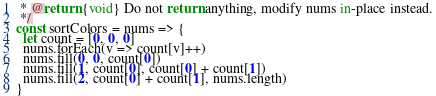Convert code to text. <code><loc_0><loc_0><loc_500><loc_500><_JavaScript_> * @return {void} Do not return anything, modify nums in-place instead.
 */
const sortColors = nums => {
  let count = [0, 0, 0]
  nums.forEach(v => count[v]++)
  nums.fill(0, 0, count[0])
  nums.fill(1, count[0], count[0] + count[1])
  nums.fill(2, count[0] + count[1], nums.length)
}</code> 